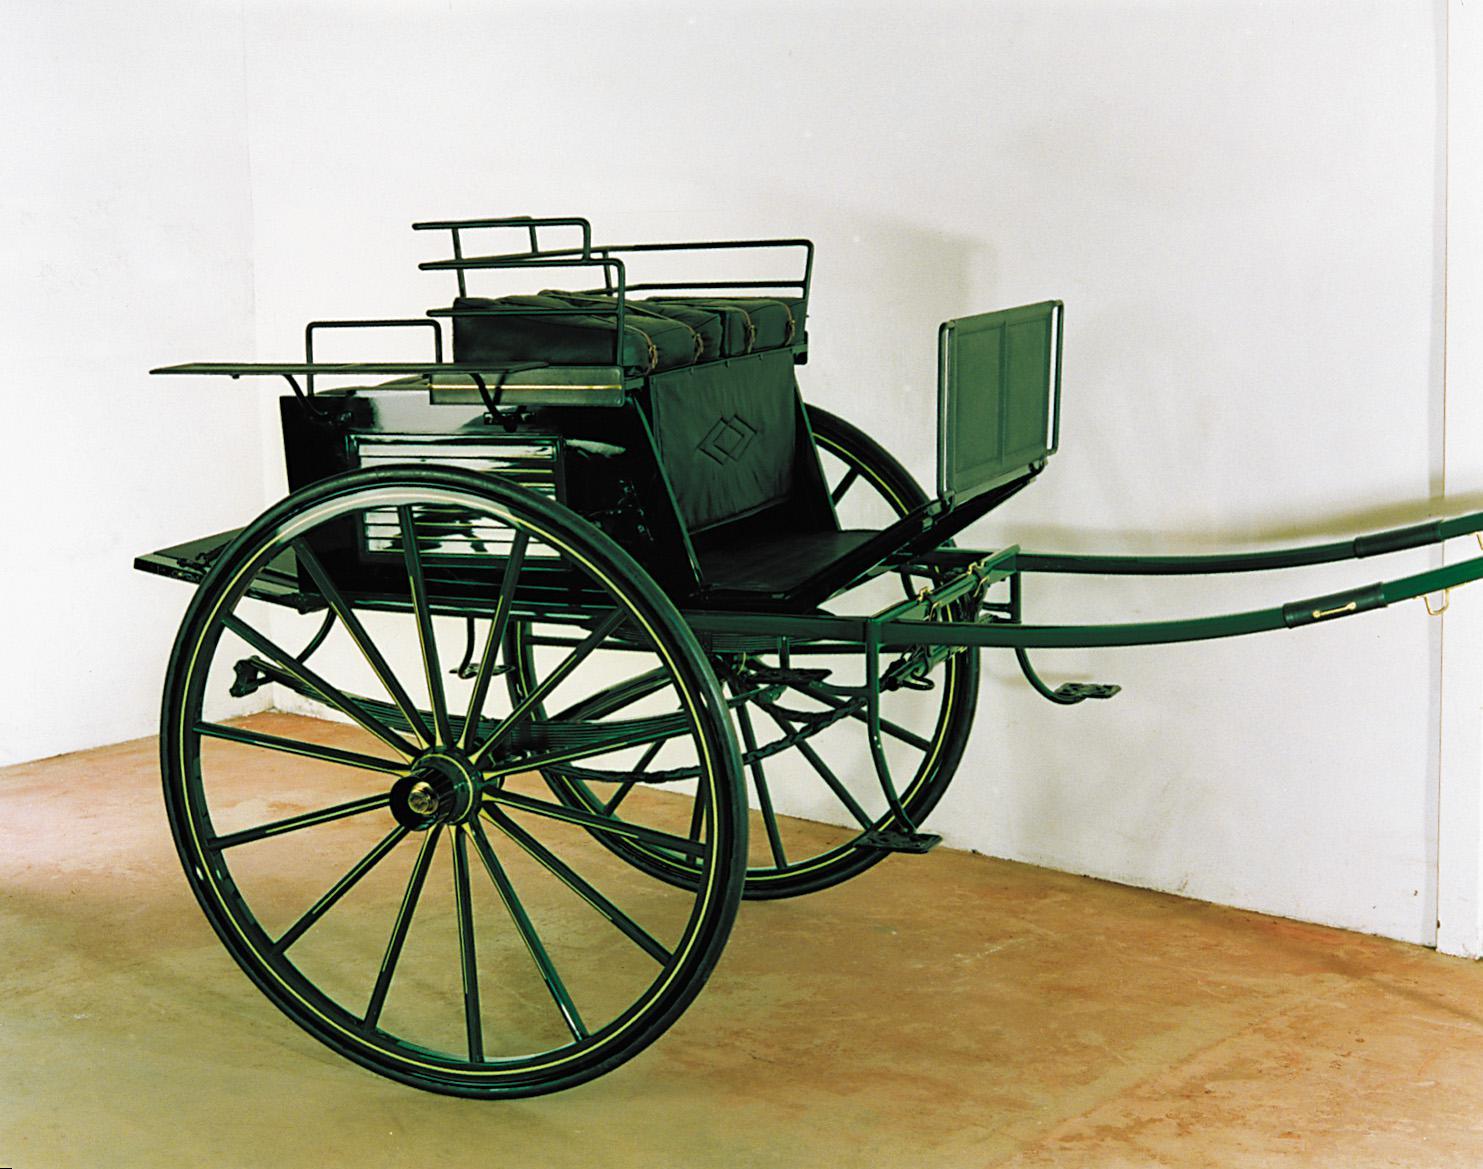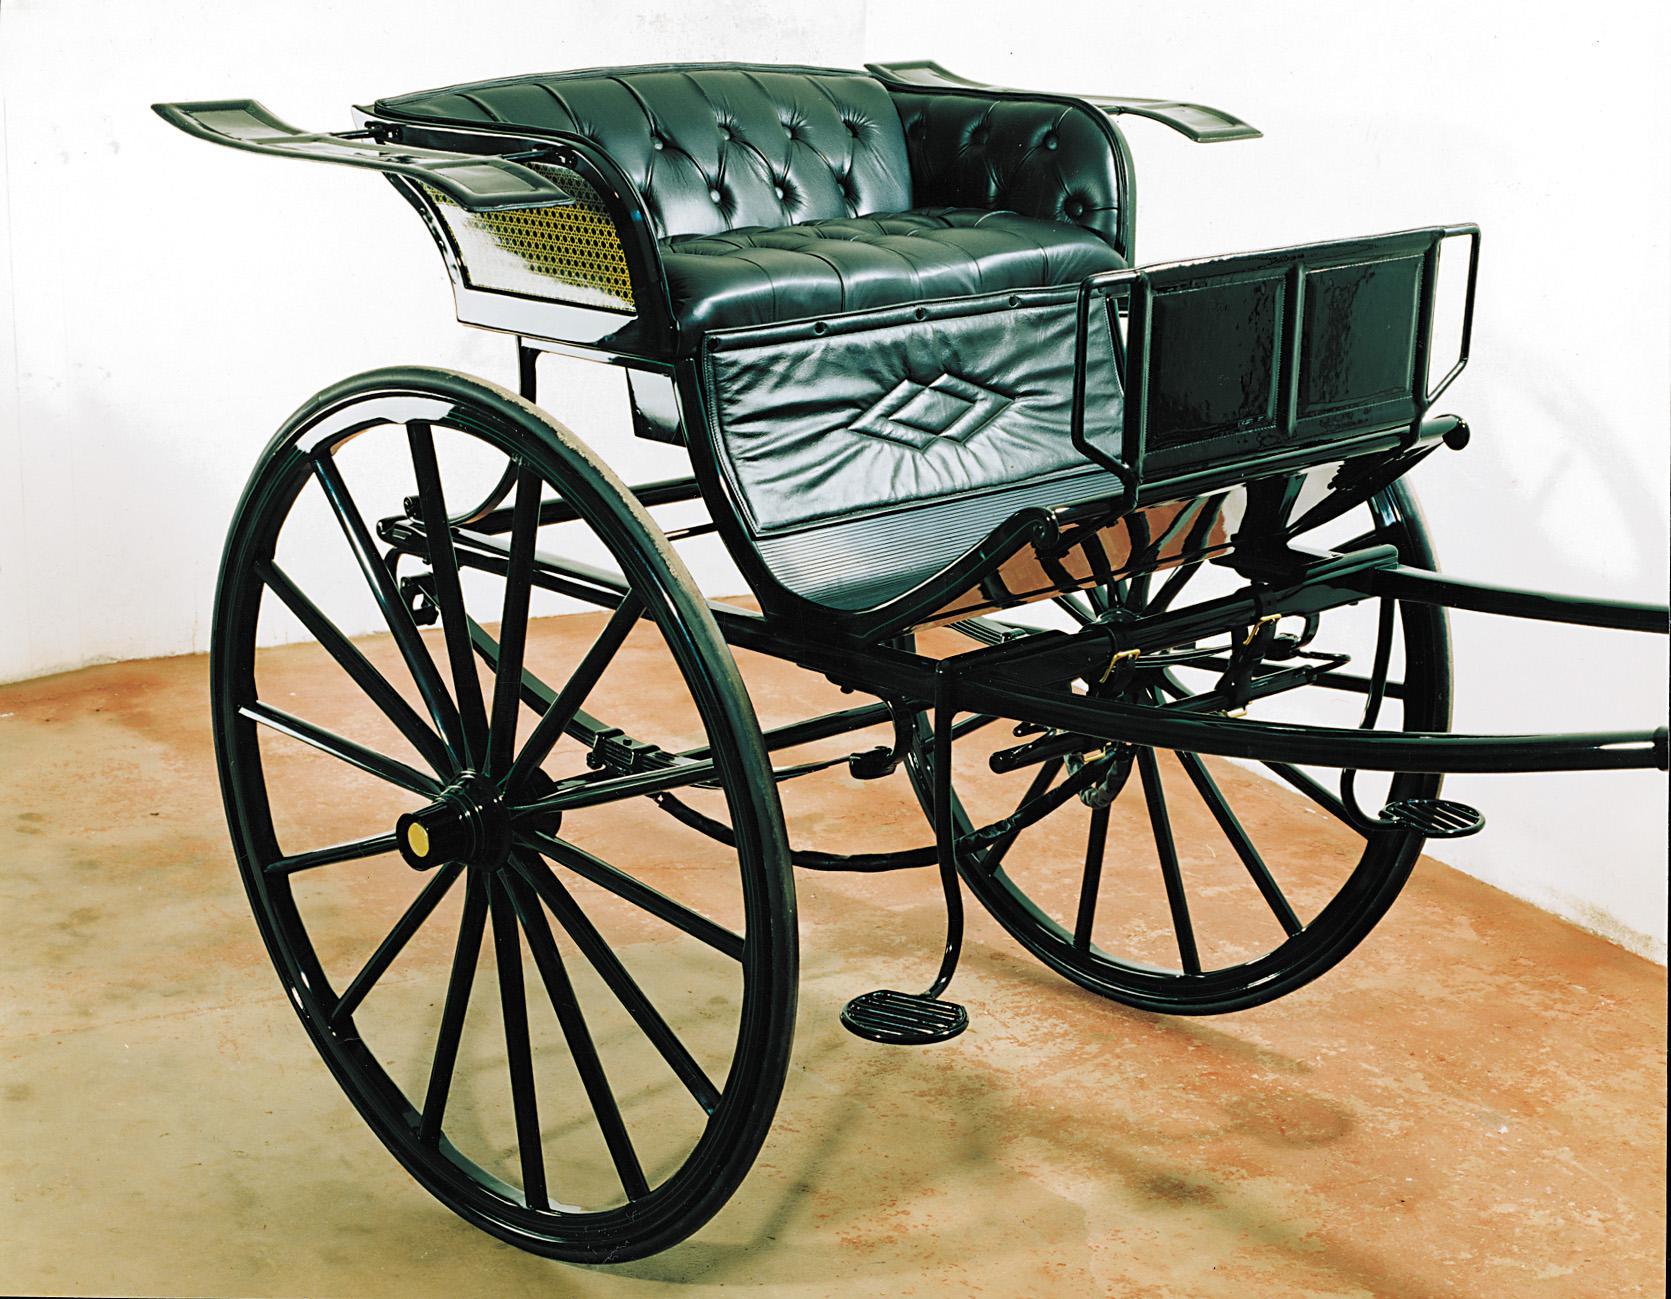The first image is the image on the left, the second image is the image on the right. Evaluate the accuracy of this statement regarding the images: "In one image, the 'handles' of the wagon are tilted to the ground.". Is it true? Answer yes or no. No. The first image is the image on the left, the second image is the image on the right. For the images shown, is this caption "The front end of one of the carts is on the ground." true? Answer yes or no. No. 